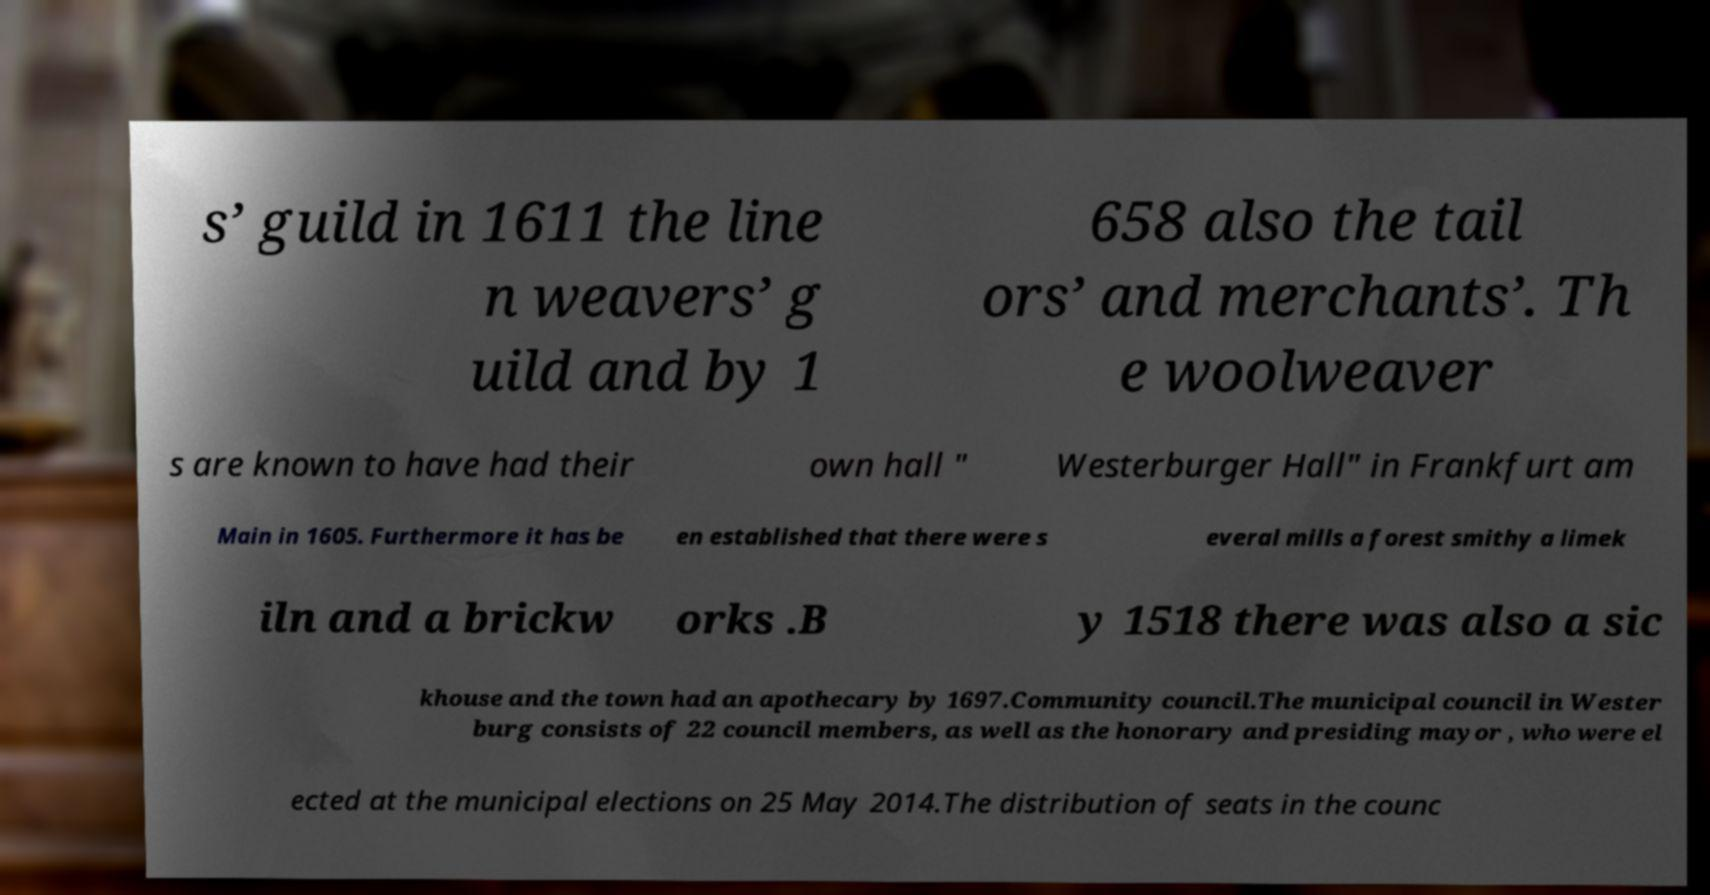There's text embedded in this image that I need extracted. Can you transcribe it verbatim? s’ guild in 1611 the line n weavers’ g uild and by 1 658 also the tail ors’ and merchants’. Th e woolweaver s are known to have had their own hall " Westerburger Hall" in Frankfurt am Main in 1605. Furthermore it has be en established that there were s everal mills a forest smithy a limek iln and a brickw orks .B y 1518 there was also a sic khouse and the town had an apothecary by 1697.Community council.The municipal council in Wester burg consists of 22 council members, as well as the honorary and presiding mayor , who were el ected at the municipal elections on 25 May 2014.The distribution of seats in the counc 